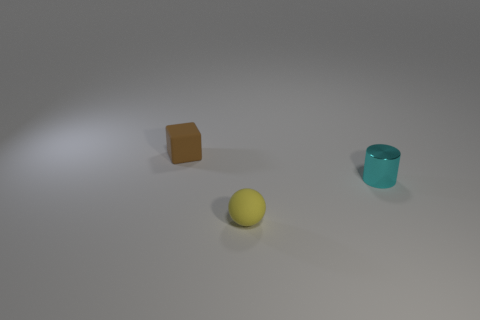Is there any other thing that is the same material as the tiny cyan cylinder?
Your answer should be compact. No. What shape is the small rubber object that is behind the tiny thing in front of the metal cylinder?
Give a very brief answer. Cube. What number of things are either tiny rubber things or metallic cylinders that are on the right side of the rubber ball?
Offer a very short reply. 3. What color is the matte thing on the left side of the rubber thing right of the rubber object that is behind the small cyan metal cylinder?
Your answer should be compact. Brown. The small metallic cylinder has what color?
Offer a terse response. Cyan. Is the color of the small shiny thing the same as the tiny block?
Keep it short and to the point. No. What number of rubber things are cyan things or small blue objects?
Offer a very short reply. 0. There is a tiny rubber thing that is in front of the tiny rubber object behind the matte sphere; are there any rubber spheres in front of it?
Provide a short and direct response. No. What size is the block that is the same material as the yellow ball?
Your answer should be very brief. Small. Are there any small matte objects to the right of the small yellow thing?
Provide a short and direct response. No. 